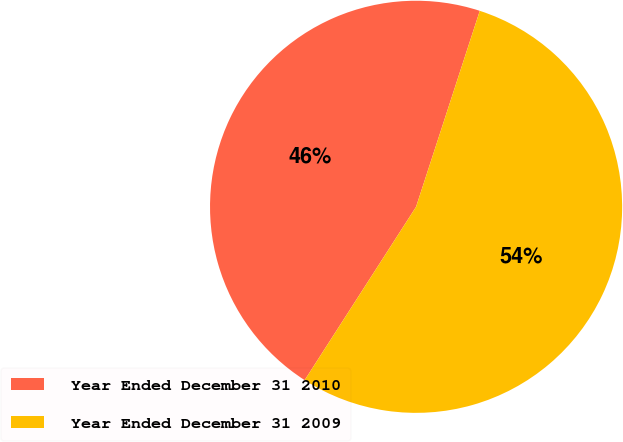<chart> <loc_0><loc_0><loc_500><loc_500><pie_chart><fcel>Year Ended December 31 2010<fcel>Year Ended December 31 2009<nl><fcel>45.91%<fcel>54.09%<nl></chart> 